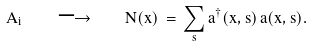Convert formula to latex. <formula><loc_0><loc_0><loc_500><loc_500>A _ { i } \quad \longrightarrow \quad N ( { x } ) \, = \, \sum _ { s } a ^ { \dagger } ( { x } , s ) \, a ( { x } , s ) .</formula> 